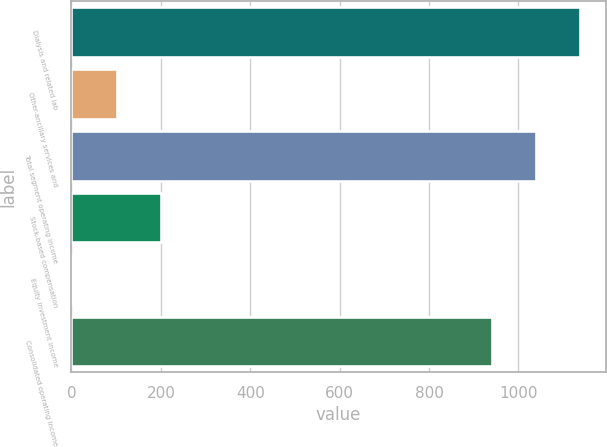Convert chart to OTSL. <chart><loc_0><loc_0><loc_500><loc_500><bar_chart><fcel>Dialysis and related lab<fcel>Other-ancillary services and<fcel>Total segment operating income<fcel>Stock-based compensation<fcel>Equity investment income<fcel>Consolidated operating income<nl><fcel>1138.4<fcel>101.2<fcel>1039.2<fcel>200.4<fcel>2<fcel>940<nl></chart> 